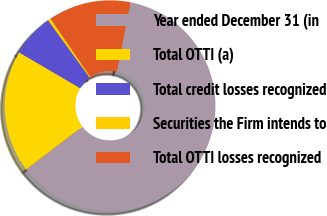<chart> <loc_0><loc_0><loc_500><loc_500><pie_chart><fcel>Year ended December 31 (in<fcel>Total OTTI (a)<fcel>Total credit losses recognized<fcel>Securities the Firm intends to<fcel>Total OTTI losses recognized<nl><fcel>61.53%<fcel>18.78%<fcel>6.57%<fcel>0.46%<fcel>12.67%<nl></chart> 